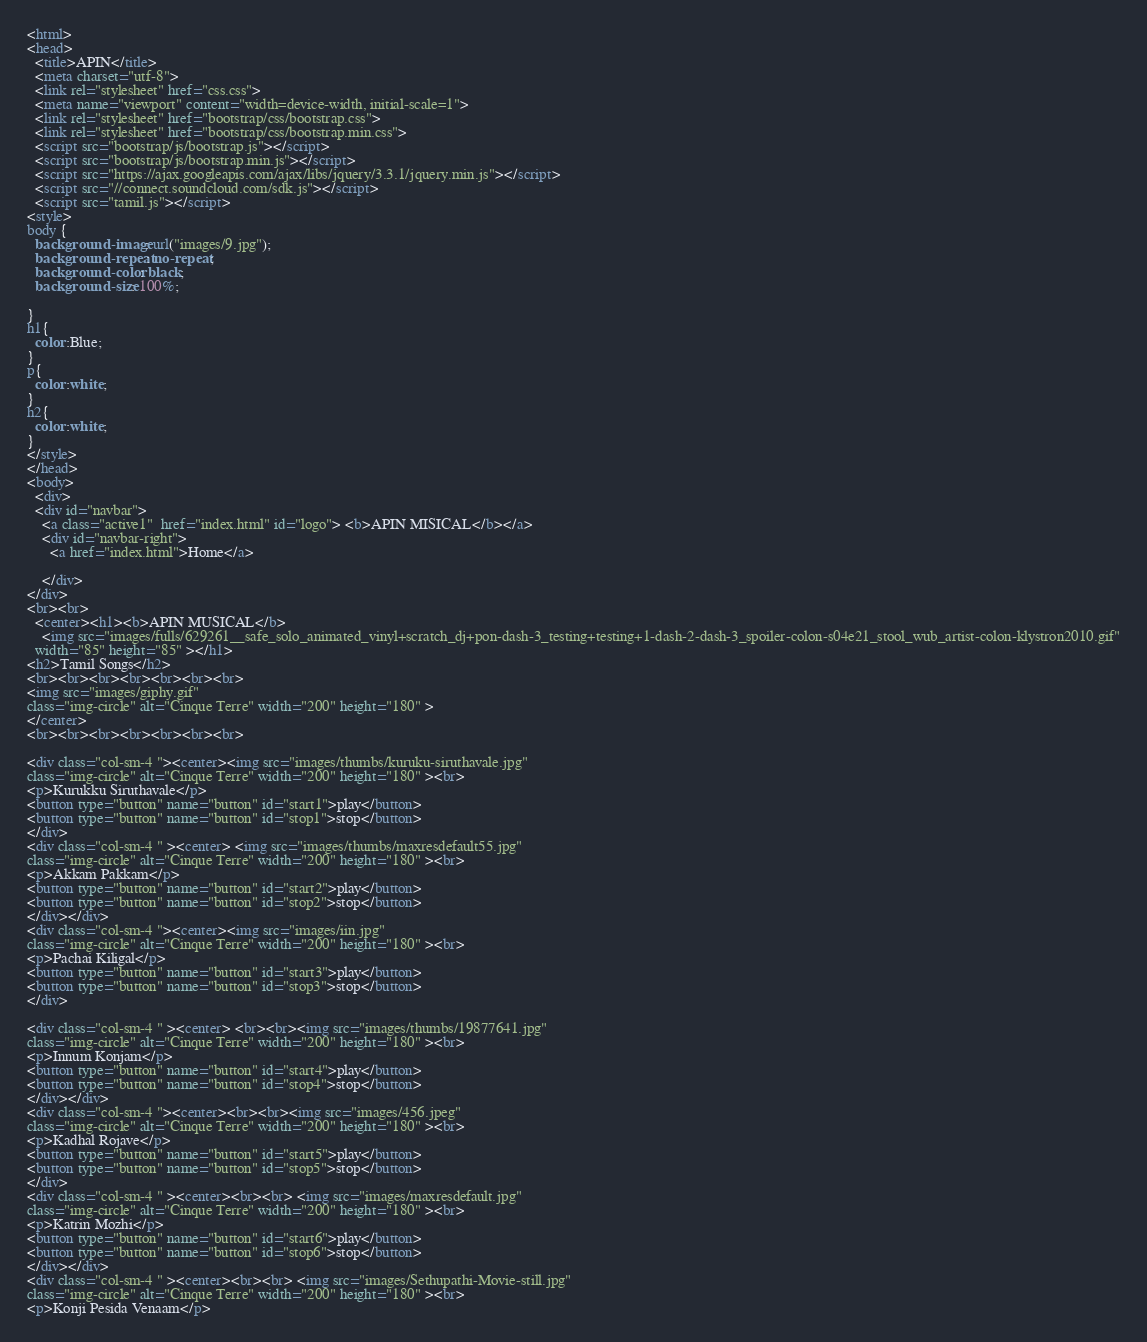<code> <loc_0><loc_0><loc_500><loc_500><_HTML_><html>
<head>
  <title>APIN</title>
  <meta charset="utf-8">
  <link rel="stylesheet" href="css.css">
  <meta name="viewport" content="width=device-width, initial-scale=1">
  <link rel="stylesheet" href="bootstrap/css/bootstrap.css">
  <link rel="stylesheet" href="bootstrap/css/bootstrap.min.css">
  <script src="bootstrap/js/bootstrap.js"></script>
  <script src="bootstrap/js/bootstrap.min.js"></script>
  <script src="https://ajax.googleapis.com/ajax/libs/jquery/3.3.1/jquery.min.js"></script>
  <script src="//connect.soundcloud.com/sdk.js"></script>
  <script src="tamil.js"></script>
<style>
body {
  background-image: url("images/9.jpg");
  background-repeat: no-repeat;
  background-color: black;
  background-size: 100%;

}
h1{
  color:Blue;
}
p{
  color:white;
}
h2{
  color:white;
}
</style>
</head>
<body>
  <div>
  <div id="navbar">
    <a class="active1"  href="index.html" id="logo"> <b>APIN MISICAL</b></a>
    <div id="navbar-right">
      <a href="index.html">Home</a>

    </div>
</div>
<br><br>
  <center><h1><b>APIN MUSICAL</b>
    <img src="images/fulls/629261__safe_solo_animated_vinyl+scratch_dj+pon-dash-3_testing+testing+1-dash-2-dash-3_spoiler-colon-s04e21_stool_wub_artist-colon-klystron2010.gif"
  width="85" height="85" ></h1>
<h2>Tamil Songs</h2>
<br><br><br><br><br><br><br>
<img src="images/giphy.gif"
class="img-circle" alt="Cinque Terre" width="200" height="180" >
</center>
<br><br><br><br><br><br><br>

<div class="col-sm-4 "><center><img src="images/thumbs/kuruku-siruthavale.jpg"
class="img-circle" alt="Cinque Terre" width="200" height="180" ><br>
<p>Kurukku Siruthavale</p>
<button type="button" name="button" id="start1">play</button>
<button type="button" name="button" id="stop1">stop</button>
</div>
<div class="col-sm-4 " ><center> <img src="images/thumbs/maxresdefault55.jpg"
class="img-circle" alt="Cinque Terre" width="200" height="180" ><br>
<p>Akkam Pakkam</p>
<button type="button" name="button" id="start2">play</button>
<button type="button" name="button" id="stop2">stop</button>
</div></div>
<div class="col-sm-4 "><center><img src="images/iin.jpg"
class="img-circle" alt="Cinque Terre" width="200" height="180" ><br>
<p>Pachai Kiligal</p>
<button type="button" name="button" id="start3">play</button>
<button type="button" name="button" id="stop3">stop</button>
</div>

<div class="col-sm-4 " ><center> <br><br><img src="images/thumbs/19877641.jpg"
class="img-circle" alt="Cinque Terre" width="200" height="180" ><br>
<p>Innum Konjam</p>
<button type="button" name="button" id="start4">play</button>
<button type="button" name="button" id="stop4">stop</button>
</div></div>
<div class="col-sm-4 "><center><br><br><img src="images/456.jpeg"
class="img-circle" alt="Cinque Terre" width="200" height="180" ><br>
<p>Kadhal Rojave</p>
<button type="button" name="button" id="start5">play</button>
<button type="button" name="button" id="stop5">stop</button>
</div>
<div class="col-sm-4 " ><center><br><br> <img src="images/maxresdefault.jpg"
class="img-circle" alt="Cinque Terre" width="200" height="180" ><br>
<p>Katrin Mozhi</p>
<button type="button" name="button" id="start6">play</button>
<button type="button" name="button" id="stop6">stop</button>
</div></div>
<div class="col-sm-4 " ><center><br><br> <img src="images/Sethupathi-Movie-still.jpg"
class="img-circle" alt="Cinque Terre" width="200" height="180" ><br>
<p>Konji Pesida Venaam</p></code> 